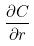Convert formula to latex. <formula><loc_0><loc_0><loc_500><loc_500>\frac { \partial C } { \partial r }</formula> 